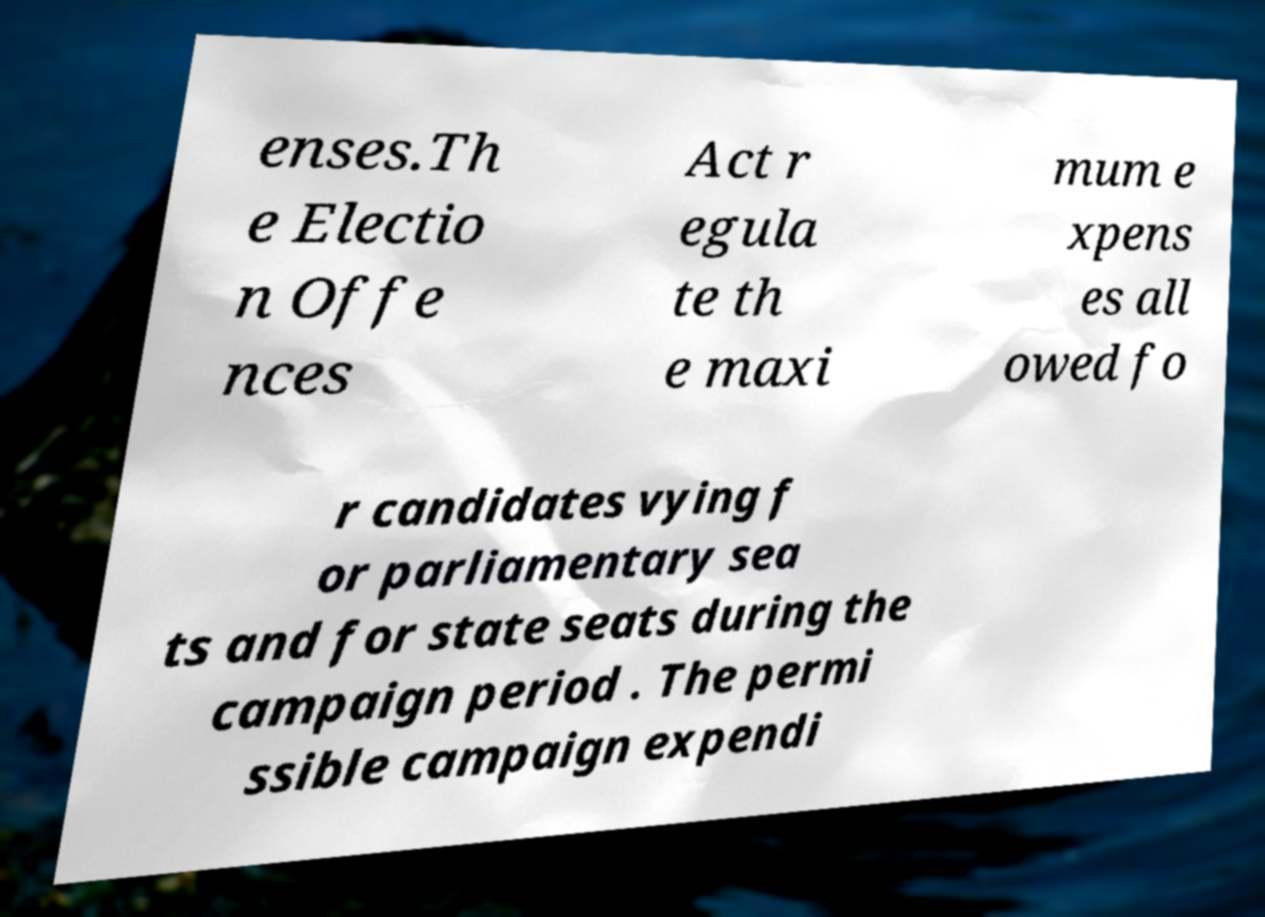Please identify and transcribe the text found in this image. enses.Th e Electio n Offe nces Act r egula te th e maxi mum e xpens es all owed fo r candidates vying f or parliamentary sea ts and for state seats during the campaign period . The permi ssible campaign expendi 